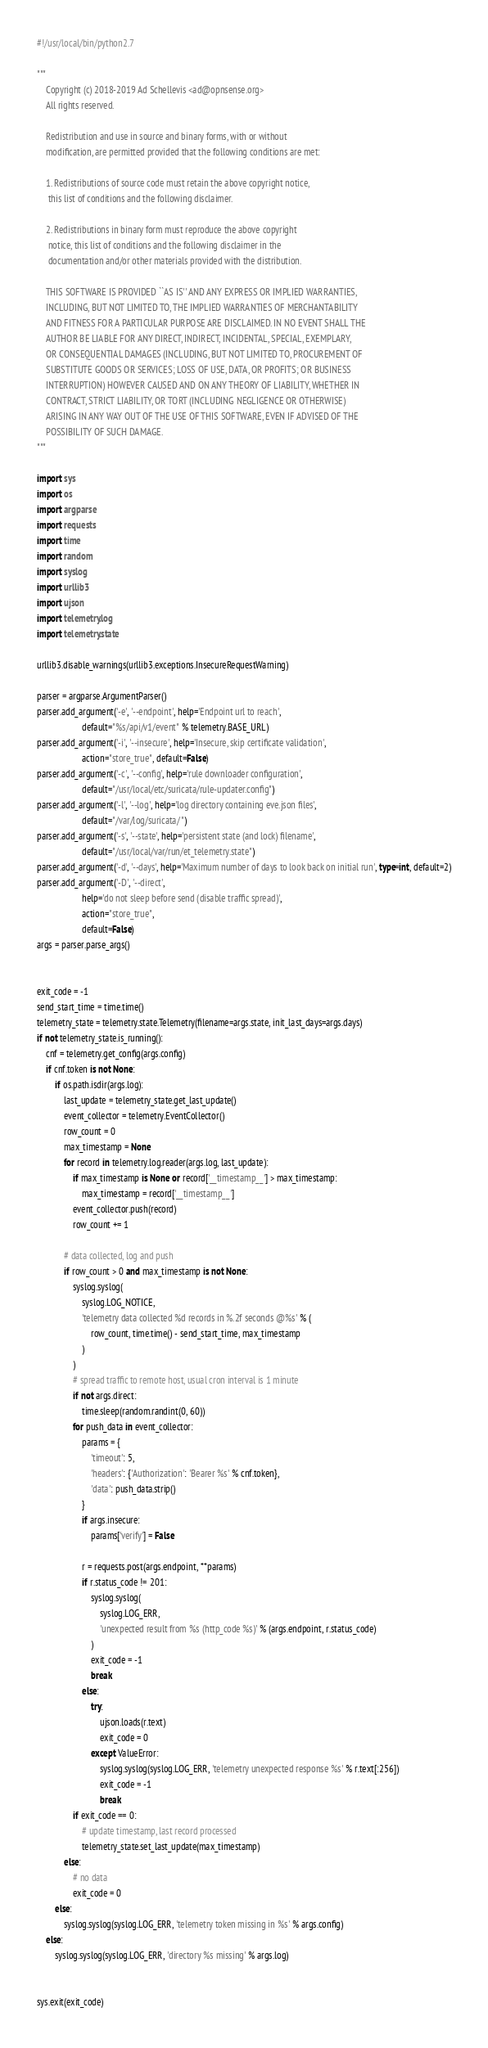Convert code to text. <code><loc_0><loc_0><loc_500><loc_500><_Python_>#!/usr/local/bin/python2.7

"""
    Copyright (c) 2018-2019 Ad Schellevis <ad@opnsense.org>
    All rights reserved.

    Redistribution and use in source and binary forms, with or without
    modification, are permitted provided that the following conditions are met:

    1. Redistributions of source code must retain the above copyright notice,
     this list of conditions and the following disclaimer.

    2. Redistributions in binary form must reproduce the above copyright
     notice, this list of conditions and the following disclaimer in the
     documentation and/or other materials provided with the distribution.

    THIS SOFTWARE IS PROVIDED ``AS IS'' AND ANY EXPRESS OR IMPLIED WARRANTIES,
    INCLUDING, BUT NOT LIMITED TO, THE IMPLIED WARRANTIES OF MERCHANTABILITY
    AND FITNESS FOR A PARTICULAR PURPOSE ARE DISCLAIMED. IN NO EVENT SHALL THE
    AUTHOR BE LIABLE FOR ANY DIRECT, INDIRECT, INCIDENTAL, SPECIAL, EXEMPLARY,
    OR CONSEQUENTIAL DAMAGES (INCLUDING, BUT NOT LIMITED TO, PROCUREMENT OF
    SUBSTITUTE GOODS OR SERVICES; LOSS OF USE, DATA, OR PROFITS; OR BUSINESS
    INTERRUPTION) HOWEVER CAUSED AND ON ANY THEORY OF LIABILITY, WHETHER IN
    CONTRACT, STRICT LIABILITY, OR TORT (INCLUDING NEGLIGENCE OR OTHERWISE)
    ARISING IN ANY WAY OUT OF THE USE OF THIS SOFTWARE, EVEN IF ADVISED OF THE
    POSSIBILITY OF SUCH DAMAGE.
"""

import sys
import os
import argparse
import requests
import time
import random
import syslog
import urllib3
import ujson
import telemetry.log
import telemetry.state

urllib3.disable_warnings(urllib3.exceptions.InsecureRequestWarning)

parser = argparse.ArgumentParser()
parser.add_argument('-e', '--endpoint', help='Endpoint url to reach',
                    default="%s/api/v1/event" % telemetry.BASE_URL)
parser.add_argument('-i', '--insecure', help='Insecure, skip certificate validation',
                    action="store_true", default=False)
parser.add_argument('-c', '--config', help='rule downloader configuration',
                    default="/usr/local/etc/suricata/rule-updater.config")
parser.add_argument('-l', '--log', help='log directory containing eve.json files',
                    default="/var/log/suricata/")
parser.add_argument('-s', '--state', help='persistent state (and lock) filename',
                    default="/usr/local/var/run/et_telemetry.state")
parser.add_argument('-d', '--days', help='Maximum number of days to look back on initial run', type=int, default=2)
parser.add_argument('-D', '--direct',
                    help='do not sleep before send (disable traffic spread)',
                    action="store_true",
                    default=False)
args = parser.parse_args()


exit_code = -1
send_start_time = time.time()
telemetry_state = telemetry.state.Telemetry(filename=args.state, init_last_days=args.days)
if not telemetry_state.is_running():
    cnf = telemetry.get_config(args.config)
    if cnf.token is not None:
        if os.path.isdir(args.log):
            last_update = telemetry_state.get_last_update()
            event_collector = telemetry.EventCollector()
            row_count = 0
            max_timestamp = None
            for record in telemetry.log.reader(args.log, last_update):
                if max_timestamp is None or record['__timestamp__'] > max_timestamp:
                    max_timestamp = record['__timestamp__']
                event_collector.push(record)
                row_count += 1

            # data collected, log and push
            if row_count > 0 and max_timestamp is not None:
                syslog.syslog(
                    syslog.LOG_NOTICE,
                    'telemetry data collected %d records in %.2f seconds @%s' % (
                        row_count, time.time() - send_start_time, max_timestamp
                    )
                )
                # spread traffic to remote host, usual cron interval is 1 minute
                if not args.direct:
                    time.sleep(random.randint(0, 60))
                for push_data in event_collector:
                    params = {
                        'timeout': 5,
                        'headers': {'Authorization': 'Bearer %s' % cnf.token},
                        'data': push_data.strip()
                    }
                    if args.insecure:
                        params['verify'] = False

                    r = requests.post(args.endpoint, **params)
                    if r.status_code != 201:
                        syslog.syslog(
                            syslog.LOG_ERR,
                            'unexpected result from %s (http_code %s)' % (args.endpoint, r.status_code)
                        )
                        exit_code = -1
                        break
                    else:
                        try:
                            ujson.loads(r.text)
                            exit_code = 0
                        except ValueError:
                            syslog.syslog(syslog.LOG_ERR, 'telemetry unexpected response %s' % r.text[:256])
                            exit_code = -1
                            break
                if exit_code == 0:
                    # update timestamp, last record processed
                    telemetry_state.set_last_update(max_timestamp)
            else:
                # no data
                exit_code = 0
        else:
            syslog.syslog(syslog.LOG_ERR, 'telemetry token missing in %s' % args.config)
    else:
        syslog.syslog(syslog.LOG_ERR, 'directory %s missing' % args.log)


sys.exit(exit_code)
</code> 